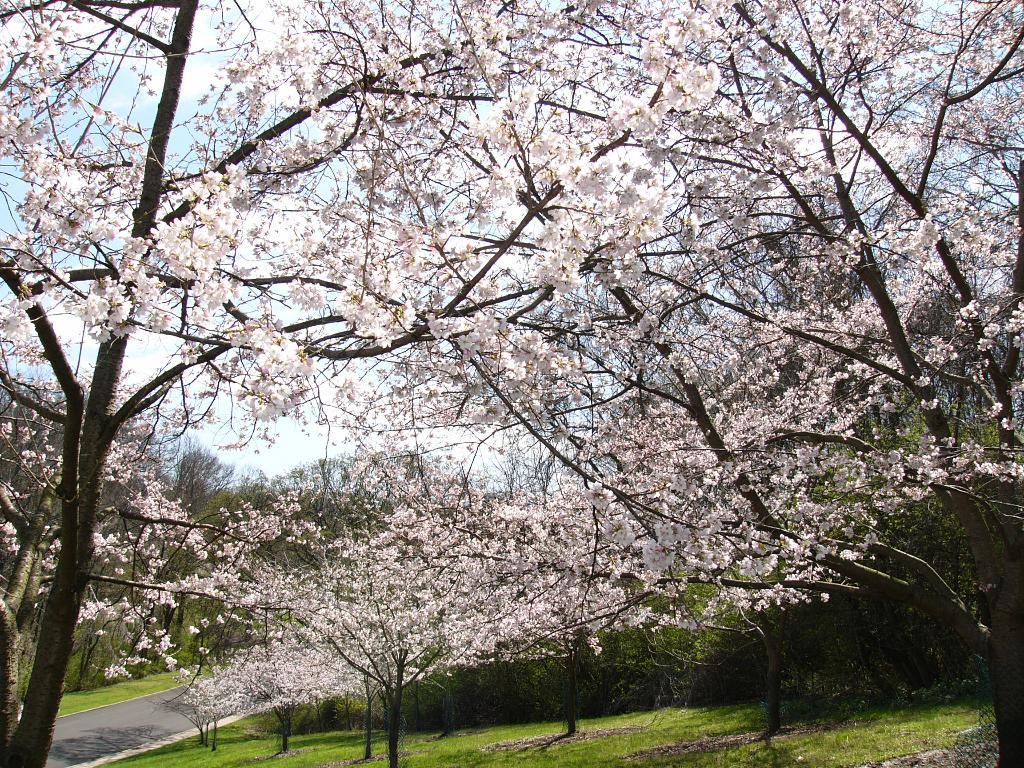What type of trees are present in the image? There are trees with white leaves in the image. What type of vegetation is visible on the ground in the image? There is grass visible in the image. Where is the road located in the image? The road is on the left side of the image. What can be seen in the background of the image? The sky is visible in the background of the image. Can you tell me how many tubs are placed near the trees in the image? There are no tubs present in the image; it features trees with white leaves, grass, a road, and the sky. What type of rail can be seen connecting the trees in the image? There is no rail connecting the trees in the image; it only shows trees with white leaves, grass, a road, and the sky. 